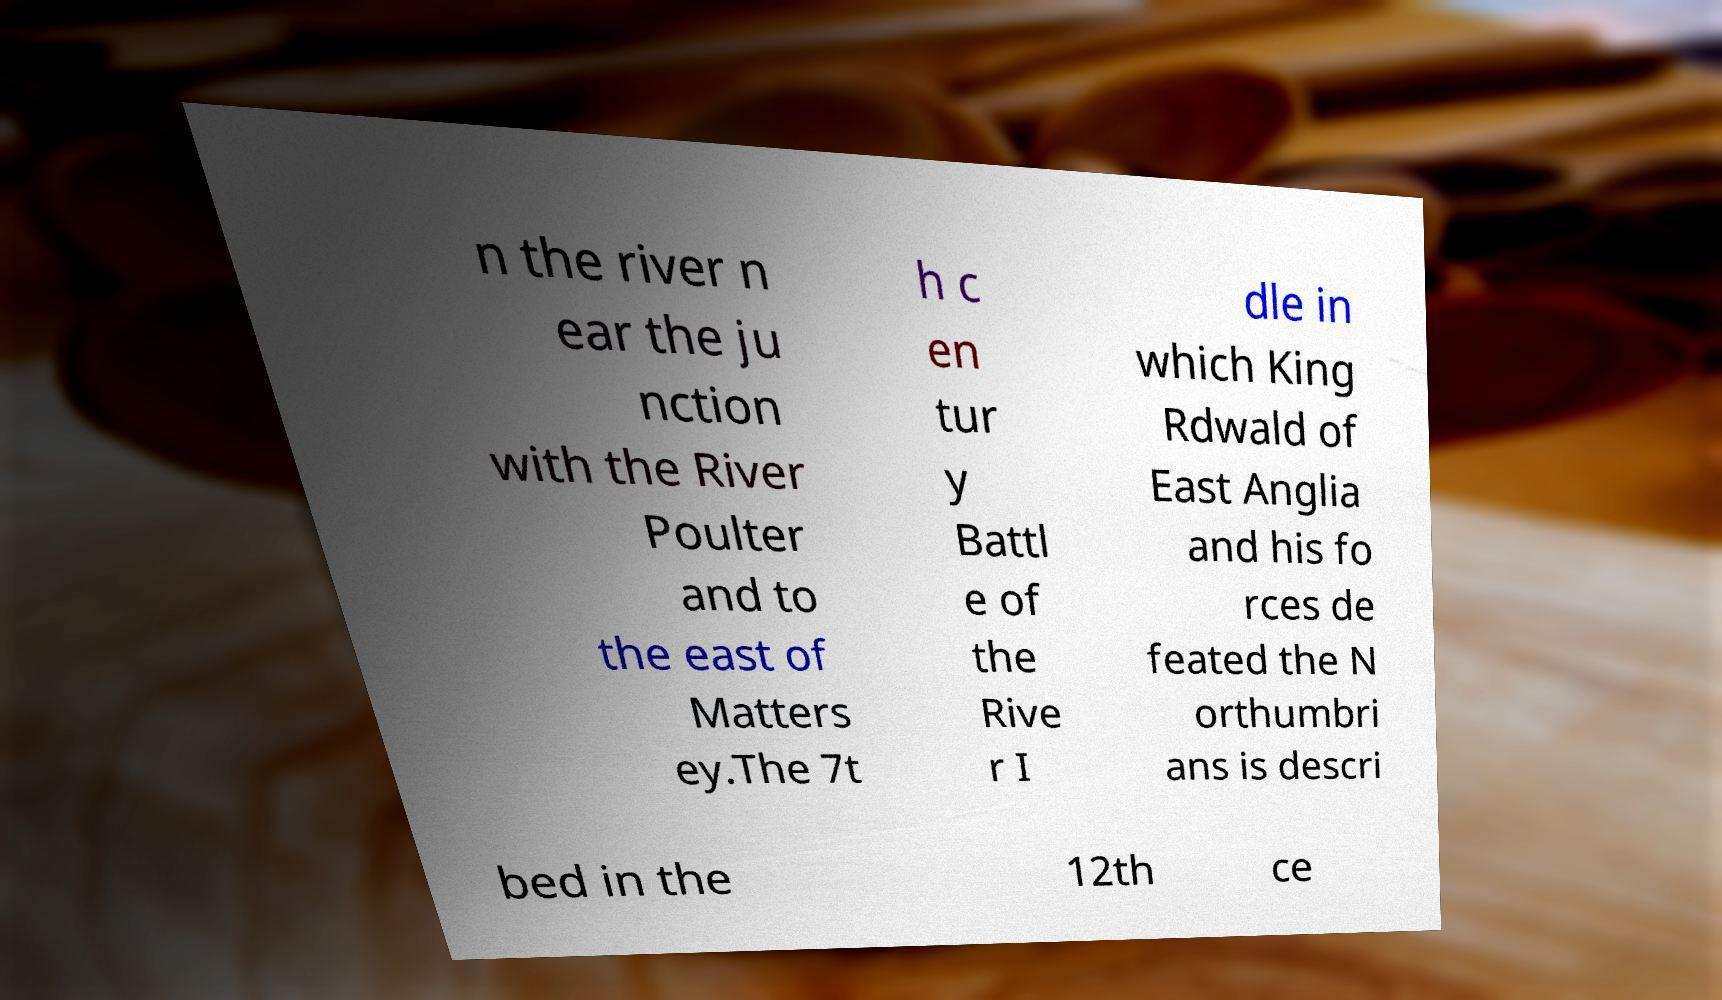Please read and relay the text visible in this image. What does it say? n the river n ear the ju nction with the River Poulter and to the east of Matters ey.The 7t h c en tur y Battl e of the Rive r I dle in which King Rdwald of East Anglia and his fo rces de feated the N orthumbri ans is descri bed in the 12th ce 